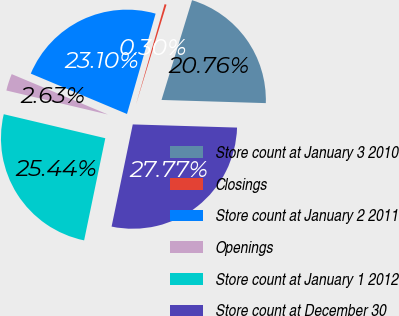Convert chart. <chart><loc_0><loc_0><loc_500><loc_500><pie_chart><fcel>Store count at January 3 2010<fcel>Closings<fcel>Store count at January 2 2011<fcel>Openings<fcel>Store count at January 1 2012<fcel>Store count at December 30<nl><fcel>20.76%<fcel>0.3%<fcel>23.1%<fcel>2.63%<fcel>25.44%<fcel>27.77%<nl></chart> 